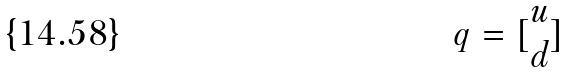Convert formula to latex. <formula><loc_0><loc_0><loc_500><loc_500>q = [ \begin{matrix} u \\ d \end{matrix} ]</formula> 